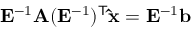<formula> <loc_0><loc_0><loc_500><loc_500>E ^ { - 1 } A ( E ^ { - 1 } ) ^ { T } \hat { x } = E ^ { - 1 } b</formula> 